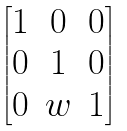<formula> <loc_0><loc_0><loc_500><loc_500>\begin{bmatrix} 1 & 0 & 0 \\ 0 & 1 & 0 \\ 0 & w & 1 \end{bmatrix}</formula> 